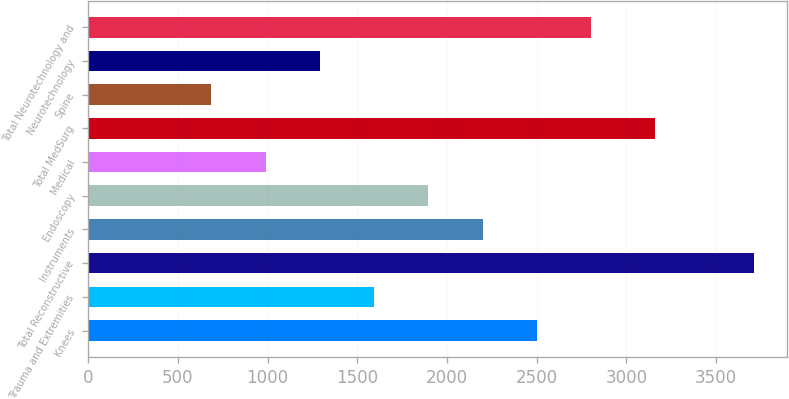Convert chart to OTSL. <chart><loc_0><loc_0><loc_500><loc_500><bar_chart><fcel>Knees<fcel>Trauma and Extremities<fcel>Total Reconstructive<fcel>Instruments<fcel>Endoscopy<fcel>Medical<fcel>Total MedSurg<fcel>Spine<fcel>Neurotechnology<fcel>Total Neurotechnology and<nl><fcel>2500.8<fcel>1593.9<fcel>3710<fcel>2198.5<fcel>1896.2<fcel>989.3<fcel>3160<fcel>687<fcel>1291.6<fcel>2803.1<nl></chart> 